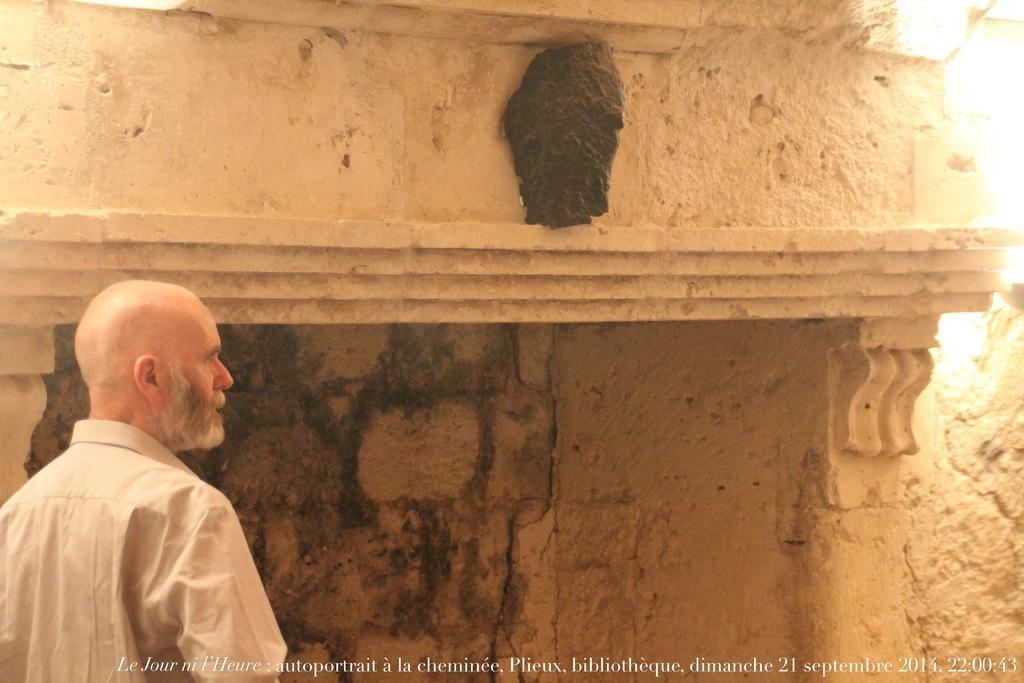Can you describe this image briefly? In the picture we can see person wearing white color dress standing and in the background there is a wall. 